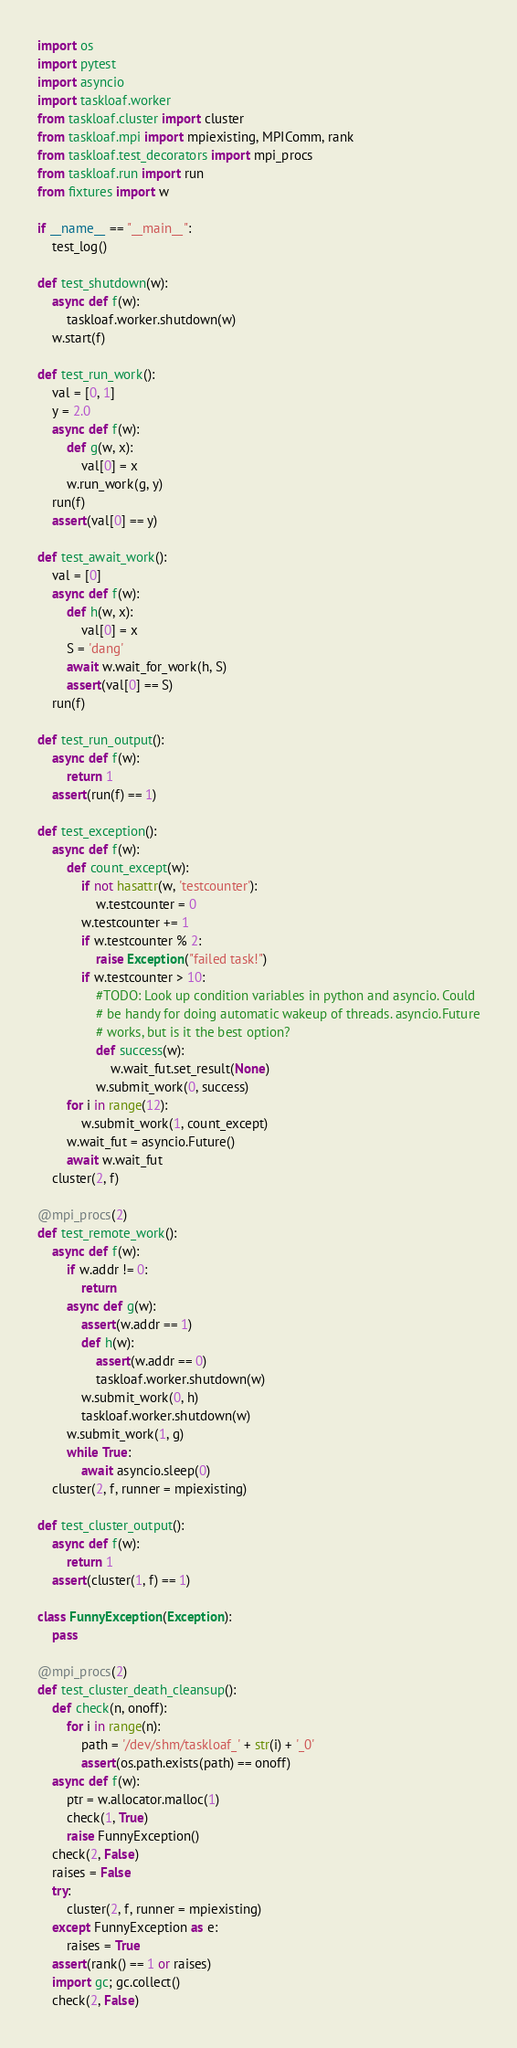Convert code to text. <code><loc_0><loc_0><loc_500><loc_500><_Python_>import os
import pytest
import asyncio
import taskloaf.worker
from taskloaf.cluster import cluster
from taskloaf.mpi import mpiexisting, MPIComm, rank
from taskloaf.test_decorators import mpi_procs
from taskloaf.run import run
from fixtures import w

if __name__ == "__main__":
    test_log()

def test_shutdown(w):
    async def f(w):
        taskloaf.worker.shutdown(w)
    w.start(f)

def test_run_work():
    val = [0, 1]
    y = 2.0
    async def f(w):
        def g(w, x):
            val[0] = x
        w.run_work(g, y)
    run(f)
    assert(val[0] == y)

def test_await_work():
    val = [0]
    async def f(w):
        def h(w, x):
            val[0] = x
        S = 'dang'
        await w.wait_for_work(h, S)
        assert(val[0] == S)
    run(f)

def test_run_output():
    async def f(w):
        return 1
    assert(run(f) == 1)

def test_exception():
    async def f(w):
        def count_except(w):
            if not hasattr(w, 'testcounter'):
                w.testcounter = 0
            w.testcounter += 1
            if w.testcounter % 2:
                raise Exception("failed task!")
            if w.testcounter > 10:
                #TODO: Look up condition variables in python and asyncio. Could
                # be handy for doing automatic wakeup of threads. asyncio.Future
                # works, but is it the best option?
                def success(w):
                    w.wait_fut.set_result(None)
                w.submit_work(0, success)
        for i in range(12):
            w.submit_work(1, count_except)
        w.wait_fut = asyncio.Future()
        await w.wait_fut
    cluster(2, f)

@mpi_procs(2)
def test_remote_work():
    async def f(w):
        if w.addr != 0:
            return
        async def g(w):
            assert(w.addr == 1)
            def h(w):
                assert(w.addr == 0)
                taskloaf.worker.shutdown(w)
            w.submit_work(0, h)
            taskloaf.worker.shutdown(w)
        w.submit_work(1, g)
        while True:
            await asyncio.sleep(0)
    cluster(2, f, runner = mpiexisting)

def test_cluster_output():
    async def f(w):
        return 1
    assert(cluster(1, f) == 1)

class FunnyException(Exception):
    pass

@mpi_procs(2)
def test_cluster_death_cleansup():
    def check(n, onoff):
        for i in range(n):
            path = '/dev/shm/taskloaf_' + str(i) + '_0'
            assert(os.path.exists(path) == onoff)
    async def f(w):
        ptr = w.allocator.malloc(1)
        check(1, True)
        raise FunnyException()
    check(2, False)
    raises = False
    try:
        cluster(2, f, runner = mpiexisting)
    except FunnyException as e:
        raises = True
    assert(rank() == 1 or raises)
    import gc; gc.collect()
    check(2, False)
</code> 